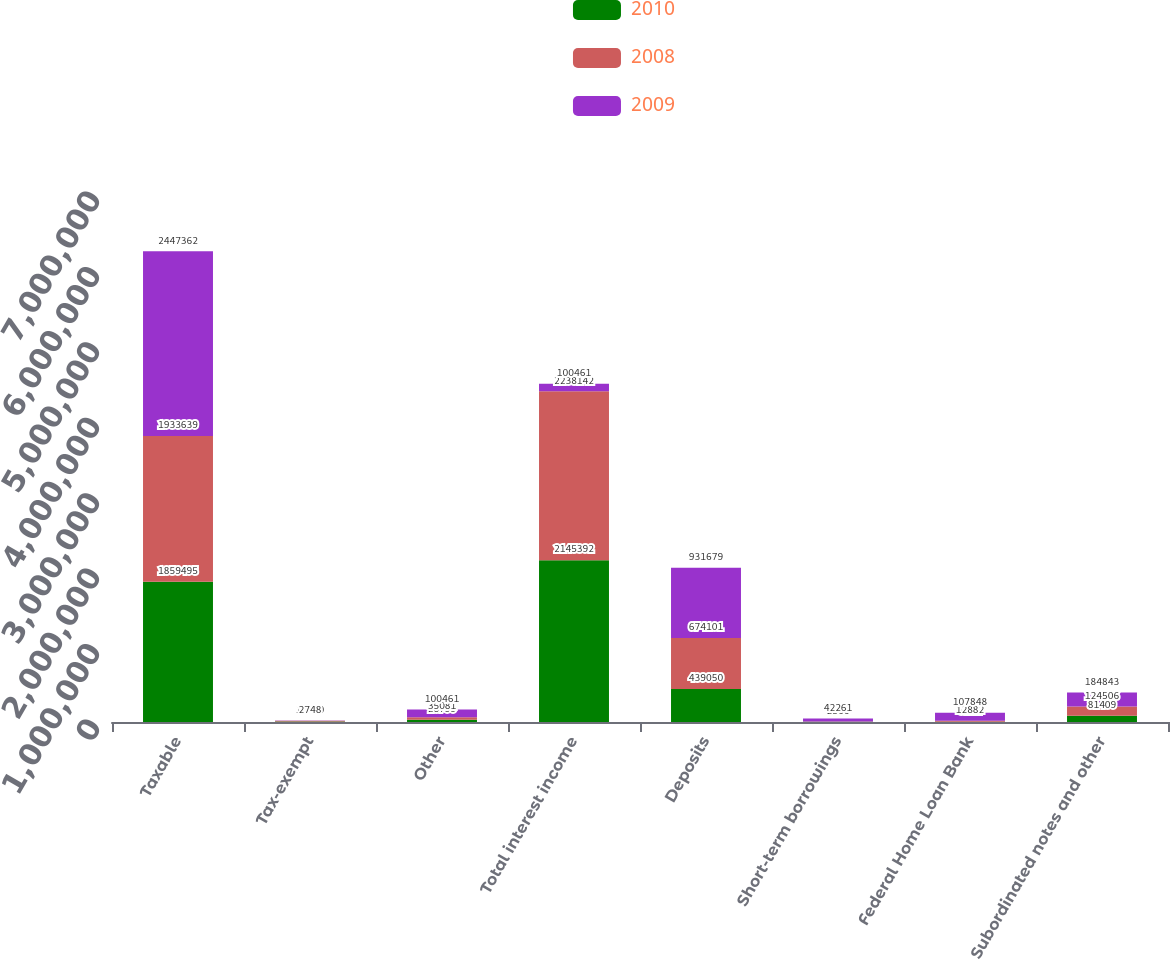Convert chart to OTSL. <chart><loc_0><loc_0><loc_500><loc_500><stacked_bar_chart><ecel><fcel>Taxable<fcel>Tax-exempt<fcel>Other<fcel>Total interest income<fcel>Deposits<fcel>Short-term borrowings<fcel>Federal Home Loan Bank<fcel>Subordinated notes and other<nl><fcel>2010<fcel>1.8595e+06<fcel>6353<fcel>28799<fcel>2.14539e+06<fcel>439050<fcel>3007<fcel>3121<fcel>81409<nl><fcel>2008<fcel>1.93364e+06<fcel>10630<fcel>35081<fcel>2.23814e+06<fcel>674101<fcel>2366<fcel>12882<fcel>124506<nl><fcel>2009<fcel>2.44736e+06<fcel>2748<fcel>100461<fcel>100461<fcel>931679<fcel>42261<fcel>107848<fcel>184843<nl></chart> 